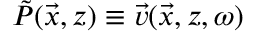<formula> <loc_0><loc_0><loc_500><loc_500>\tilde { P } ( \vec { x } , z ) \equiv \vec { v } ( \vec { x } , z , \omega )</formula> 